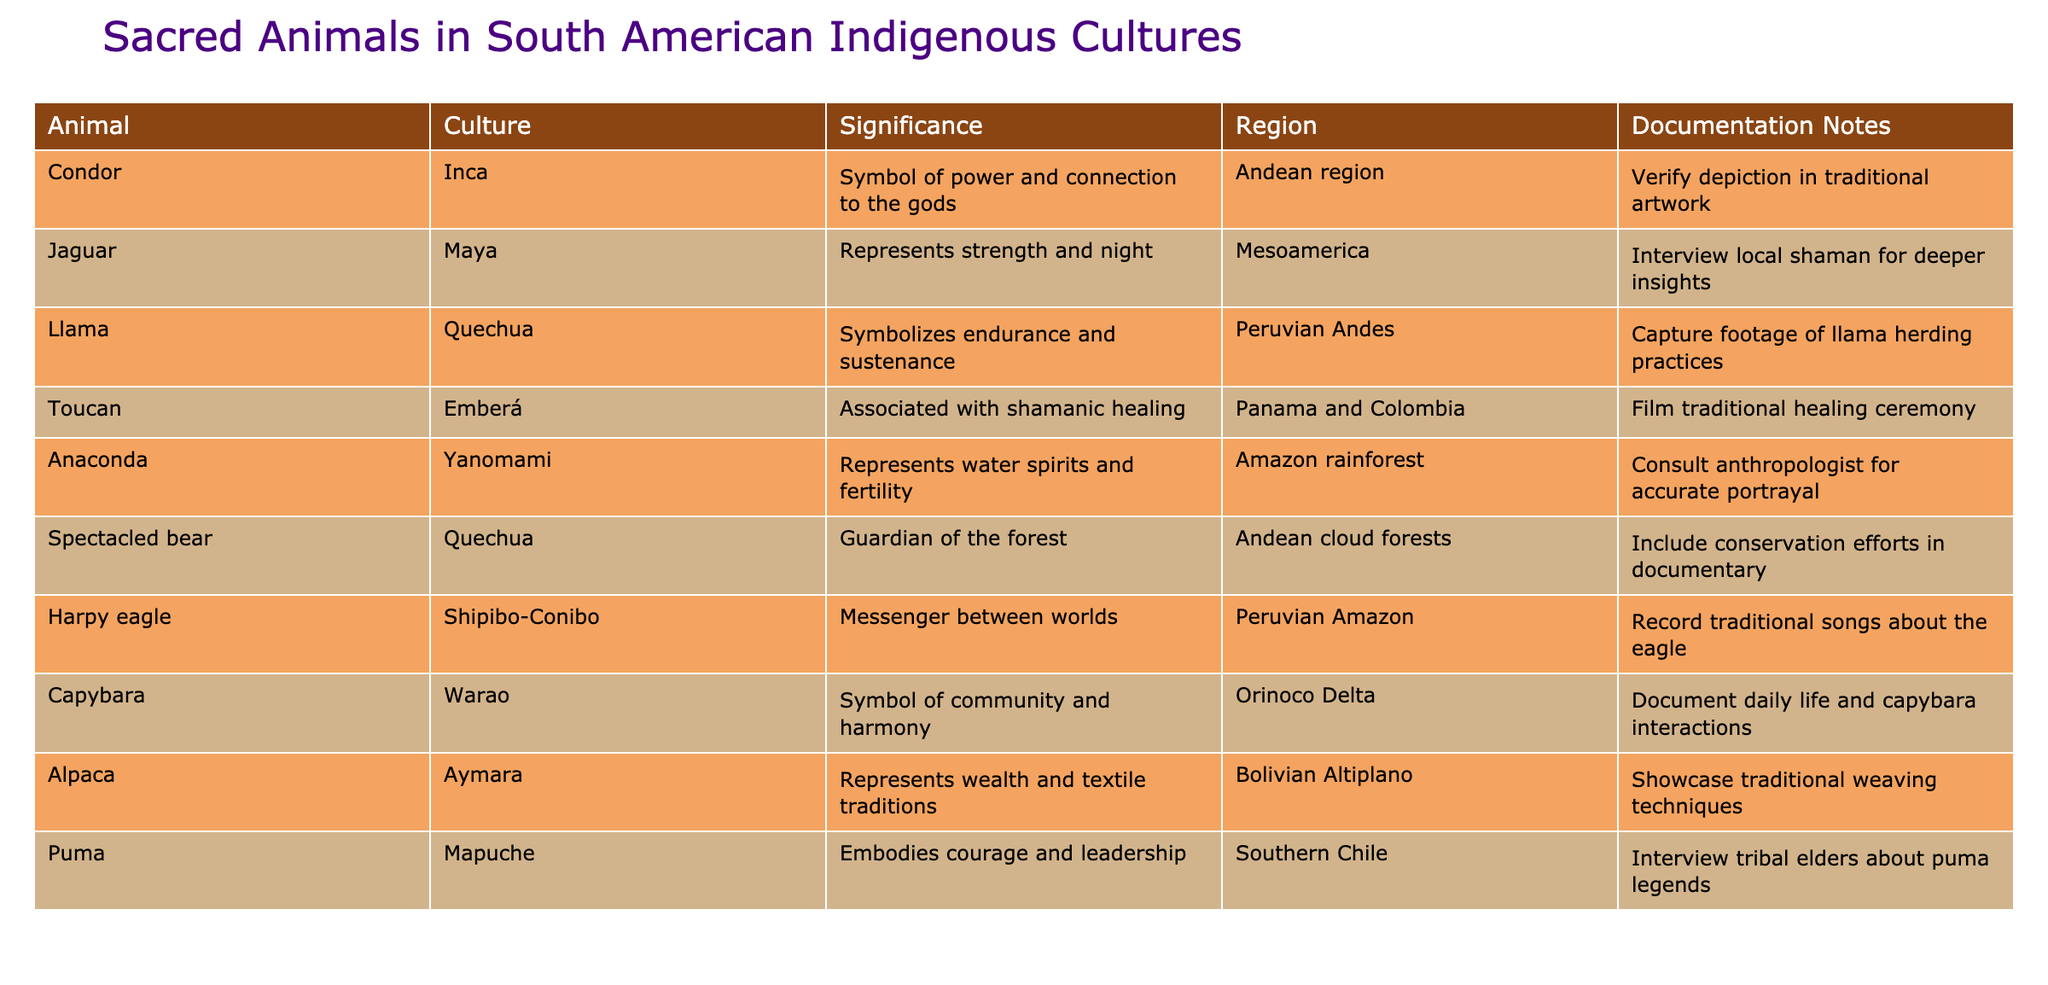What is the significance of the Condor in Inca culture? The table states that in Inca culture, the Condor symbolizes power and connection to the gods.
Answer: Symbol of power and connection to the gods Which animal represents wealth in Aymara culture? According to the table, the Alpaca represents wealth and textile traditions in Aymara culture.
Answer: Alpaca True or False: The Anaconda is associated with fertility in Yanomami culture. The table indicates that the Anaconda represents water spirits and fertility in Yanomami culture, which makes this statement true.
Answer: True What are the two significance aspects of the Jaguar in Maya culture? The table lists that the Jaguar represents strength and night in Maya culture, making these the two aspects.
Answer: Strength and night In which region is the Toucan associated with shamanic healing? The table shows that the Toucan is associated with shamanic healing in Panama and Colombia.
Answer: Panama and Colombia How many animals are specifically linked to the Andean region in this table? The table includes the Condor and Spectacled bear as sacred animals from the Andean region, giving a total of two.
Answer: 2 Which animal has documentation notes related to a traditional healing ceremony? The Toucan has documentation notes regarding filming a traditional healing ceremony.
Answer: Toucan What is the common cultural theme represented by the Capybara in Warao culture? The table indicates that the Capybara symbolizes community and harmony in Warao culture, representing positive community relations.
Answer: Community and harmony What animal signifies the guardian of the forest in Quechua culture? The Spectacled bear is noted in the table as the guardian of the forest in Quechua culture.
Answer: Spectacled bear 